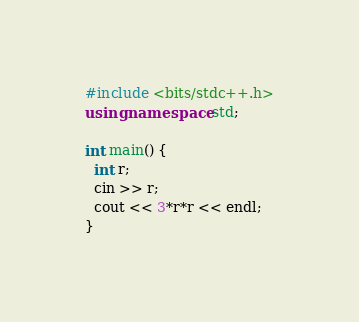<code> <loc_0><loc_0><loc_500><loc_500><_C++_>#include <bits/stdc++.h>
using namespace std;

int main() {
  int r;
  cin >> r;
  cout << 3*r*r << endl;
}

</code> 